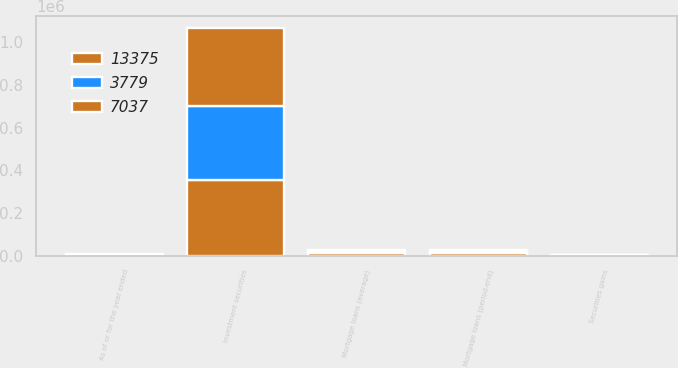<chart> <loc_0><loc_0><loc_500><loc_500><stacked_bar_chart><ecel><fcel>As of or for the year ended<fcel>Securities gains<fcel>Investment securities<fcel>Mortgage loans (average)<fcel>Mortgage loans (period-end)<nl><fcel>3779<fcel>2013<fcel>659<fcel>347562<fcel>5145<fcel>3779<nl><fcel>7037<fcel>2012<fcel>2028<fcel>365421<fcel>10241<fcel>7037<nl><fcel>13375<fcel>2011<fcel>1385<fcel>355605<fcel>13006<fcel>13375<nl></chart> 